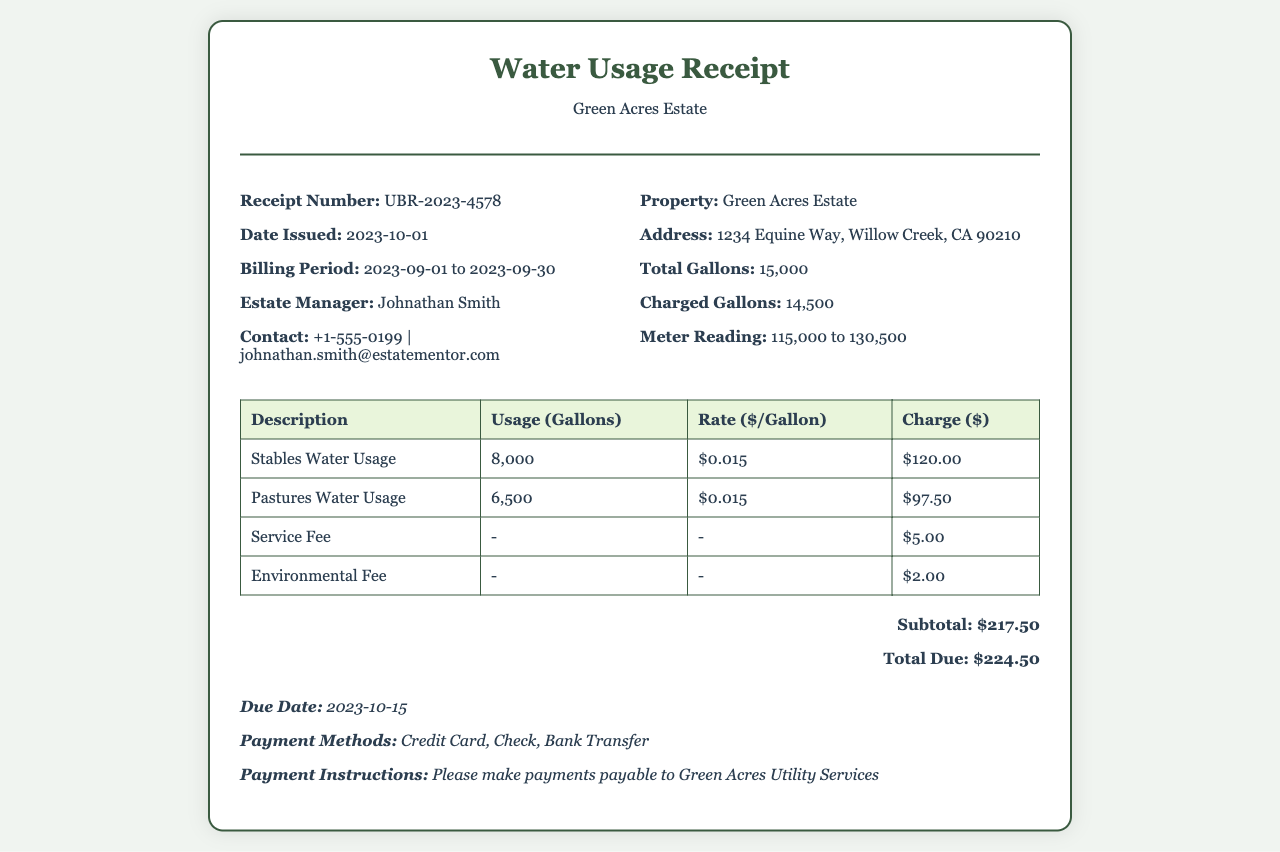What is the receipt number? The receipt number is a unique identifier for this specific bill, which can be found in the top section of the document.
Answer: UBR-2023-4578 What is the total charged gallons? The total charged gallons represent the amount billed for water usage, listed in the details section.
Answer: 14,500 Who is the estate manager? The estate manager's name is provided in the details section of the receipt.
Answer: Johnathan Smith What is the subtotal amount? The subtotal amount is the sum of the charges before any additional fees, located at the bottom of the charges table.
Answer: $217.50 How much is the charge for stables water usage? The charge specifically for stables water usage is shown in the charges table under that description.
Answer: $120.00 What is the due date for the payment? The due date indicates when the payment must be made and is clearly stated towards the bottom of the receipt.
Answer: 2023-10-15 What is included in the total due? The total due is the sum of the subtotal and any additional fees and is computed at the bottom of the receipt.
Answer: $224.50 What type of payment methods are accepted? This specifies the methods by which payment can be made, which is listed in the payment information section.
Answer: Credit Card, Check, Bank Transfer What rate is charged per gallon for pastures water usage? This is the cost per gallon for water used in pastures, which can be found in the detailed breakdown of charges.
Answer: $0.015 